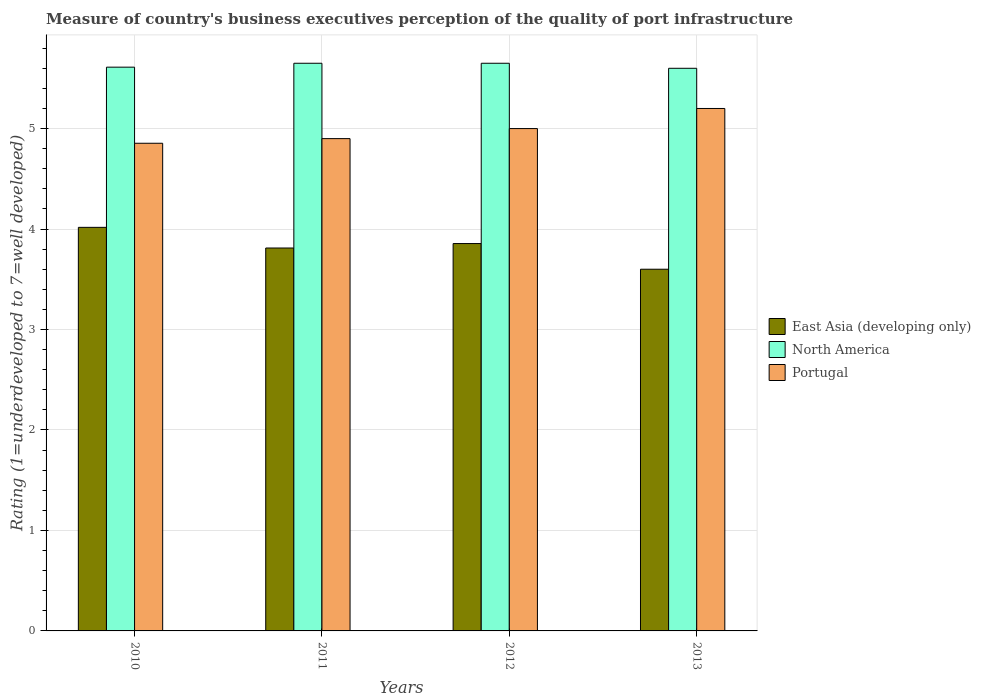How many different coloured bars are there?
Your response must be concise. 3. How many groups of bars are there?
Your answer should be compact. 4. Are the number of bars per tick equal to the number of legend labels?
Your answer should be very brief. Yes. How many bars are there on the 2nd tick from the right?
Make the answer very short. 3. What is the label of the 1st group of bars from the left?
Ensure brevity in your answer.  2010. What is the ratings of the quality of port infrastructure in North America in 2010?
Your answer should be very brief. 5.61. Across all years, what is the maximum ratings of the quality of port infrastructure in East Asia (developing only)?
Keep it short and to the point. 4.02. In which year was the ratings of the quality of port infrastructure in North America maximum?
Make the answer very short. 2011. In which year was the ratings of the quality of port infrastructure in Portugal minimum?
Your response must be concise. 2010. What is the total ratings of the quality of port infrastructure in Portugal in the graph?
Provide a short and direct response. 19.95. What is the difference between the ratings of the quality of port infrastructure in Portugal in 2010 and that in 2013?
Give a very brief answer. -0.35. What is the difference between the ratings of the quality of port infrastructure in Portugal in 2012 and the ratings of the quality of port infrastructure in North America in 2013?
Make the answer very short. -0.6. What is the average ratings of the quality of port infrastructure in North America per year?
Make the answer very short. 5.63. In the year 2010, what is the difference between the ratings of the quality of port infrastructure in East Asia (developing only) and ratings of the quality of port infrastructure in Portugal?
Your answer should be very brief. -0.84. What is the ratio of the ratings of the quality of port infrastructure in Portugal in 2010 to that in 2012?
Provide a short and direct response. 0.97. Is the ratings of the quality of port infrastructure in Portugal in 2010 less than that in 2013?
Provide a short and direct response. Yes. Is the difference between the ratings of the quality of port infrastructure in East Asia (developing only) in 2010 and 2012 greater than the difference between the ratings of the quality of port infrastructure in Portugal in 2010 and 2012?
Keep it short and to the point. Yes. What is the difference between the highest and the second highest ratings of the quality of port infrastructure in Portugal?
Your answer should be compact. 0.2. What is the difference between the highest and the lowest ratings of the quality of port infrastructure in East Asia (developing only)?
Make the answer very short. 0.42. In how many years, is the ratings of the quality of port infrastructure in East Asia (developing only) greater than the average ratings of the quality of port infrastructure in East Asia (developing only) taken over all years?
Provide a short and direct response. 2. Is the sum of the ratings of the quality of port infrastructure in North America in 2011 and 2013 greater than the maximum ratings of the quality of port infrastructure in Portugal across all years?
Your answer should be very brief. Yes. What does the 3rd bar from the left in 2010 represents?
Offer a terse response. Portugal. What does the 3rd bar from the right in 2013 represents?
Ensure brevity in your answer.  East Asia (developing only). Is it the case that in every year, the sum of the ratings of the quality of port infrastructure in Portugal and ratings of the quality of port infrastructure in East Asia (developing only) is greater than the ratings of the quality of port infrastructure in North America?
Your answer should be very brief. Yes. Are all the bars in the graph horizontal?
Your answer should be compact. No. Are the values on the major ticks of Y-axis written in scientific E-notation?
Provide a short and direct response. No. Does the graph contain any zero values?
Offer a very short reply. No. How many legend labels are there?
Provide a short and direct response. 3. How are the legend labels stacked?
Your answer should be very brief. Vertical. What is the title of the graph?
Give a very brief answer. Measure of country's business executives perception of the quality of port infrastructure. Does "Korea (Democratic)" appear as one of the legend labels in the graph?
Keep it short and to the point. No. What is the label or title of the Y-axis?
Offer a terse response. Rating (1=underdeveloped to 7=well developed). What is the Rating (1=underdeveloped to 7=well developed) of East Asia (developing only) in 2010?
Offer a very short reply. 4.02. What is the Rating (1=underdeveloped to 7=well developed) in North America in 2010?
Your answer should be very brief. 5.61. What is the Rating (1=underdeveloped to 7=well developed) in Portugal in 2010?
Your answer should be compact. 4.85. What is the Rating (1=underdeveloped to 7=well developed) in East Asia (developing only) in 2011?
Keep it short and to the point. 3.81. What is the Rating (1=underdeveloped to 7=well developed) in North America in 2011?
Offer a terse response. 5.65. What is the Rating (1=underdeveloped to 7=well developed) in Portugal in 2011?
Your answer should be compact. 4.9. What is the Rating (1=underdeveloped to 7=well developed) in East Asia (developing only) in 2012?
Keep it short and to the point. 3.86. What is the Rating (1=underdeveloped to 7=well developed) of North America in 2012?
Give a very brief answer. 5.65. Across all years, what is the maximum Rating (1=underdeveloped to 7=well developed) in East Asia (developing only)?
Give a very brief answer. 4.02. Across all years, what is the maximum Rating (1=underdeveloped to 7=well developed) of North America?
Offer a terse response. 5.65. Across all years, what is the minimum Rating (1=underdeveloped to 7=well developed) of East Asia (developing only)?
Your answer should be compact. 3.6. Across all years, what is the minimum Rating (1=underdeveloped to 7=well developed) of Portugal?
Keep it short and to the point. 4.85. What is the total Rating (1=underdeveloped to 7=well developed) in East Asia (developing only) in the graph?
Keep it short and to the point. 15.28. What is the total Rating (1=underdeveloped to 7=well developed) in North America in the graph?
Offer a terse response. 22.51. What is the total Rating (1=underdeveloped to 7=well developed) of Portugal in the graph?
Make the answer very short. 19.95. What is the difference between the Rating (1=underdeveloped to 7=well developed) of East Asia (developing only) in 2010 and that in 2011?
Your response must be concise. 0.21. What is the difference between the Rating (1=underdeveloped to 7=well developed) of North America in 2010 and that in 2011?
Keep it short and to the point. -0.04. What is the difference between the Rating (1=underdeveloped to 7=well developed) in Portugal in 2010 and that in 2011?
Your response must be concise. -0.05. What is the difference between the Rating (1=underdeveloped to 7=well developed) of East Asia (developing only) in 2010 and that in 2012?
Keep it short and to the point. 0.16. What is the difference between the Rating (1=underdeveloped to 7=well developed) in North America in 2010 and that in 2012?
Your answer should be compact. -0.04. What is the difference between the Rating (1=underdeveloped to 7=well developed) of Portugal in 2010 and that in 2012?
Your answer should be very brief. -0.15. What is the difference between the Rating (1=underdeveloped to 7=well developed) in East Asia (developing only) in 2010 and that in 2013?
Provide a short and direct response. 0.42. What is the difference between the Rating (1=underdeveloped to 7=well developed) of North America in 2010 and that in 2013?
Ensure brevity in your answer.  0.01. What is the difference between the Rating (1=underdeveloped to 7=well developed) of Portugal in 2010 and that in 2013?
Your answer should be compact. -0.35. What is the difference between the Rating (1=underdeveloped to 7=well developed) in East Asia (developing only) in 2011 and that in 2012?
Ensure brevity in your answer.  -0.04. What is the difference between the Rating (1=underdeveloped to 7=well developed) of North America in 2011 and that in 2012?
Your response must be concise. 0. What is the difference between the Rating (1=underdeveloped to 7=well developed) of East Asia (developing only) in 2011 and that in 2013?
Ensure brevity in your answer.  0.21. What is the difference between the Rating (1=underdeveloped to 7=well developed) of Portugal in 2011 and that in 2013?
Ensure brevity in your answer.  -0.3. What is the difference between the Rating (1=underdeveloped to 7=well developed) in East Asia (developing only) in 2012 and that in 2013?
Your answer should be compact. 0.26. What is the difference between the Rating (1=underdeveloped to 7=well developed) in North America in 2012 and that in 2013?
Ensure brevity in your answer.  0.05. What is the difference between the Rating (1=underdeveloped to 7=well developed) in East Asia (developing only) in 2010 and the Rating (1=underdeveloped to 7=well developed) in North America in 2011?
Keep it short and to the point. -1.63. What is the difference between the Rating (1=underdeveloped to 7=well developed) in East Asia (developing only) in 2010 and the Rating (1=underdeveloped to 7=well developed) in Portugal in 2011?
Make the answer very short. -0.88. What is the difference between the Rating (1=underdeveloped to 7=well developed) in North America in 2010 and the Rating (1=underdeveloped to 7=well developed) in Portugal in 2011?
Keep it short and to the point. 0.71. What is the difference between the Rating (1=underdeveloped to 7=well developed) in East Asia (developing only) in 2010 and the Rating (1=underdeveloped to 7=well developed) in North America in 2012?
Offer a very short reply. -1.63. What is the difference between the Rating (1=underdeveloped to 7=well developed) in East Asia (developing only) in 2010 and the Rating (1=underdeveloped to 7=well developed) in Portugal in 2012?
Ensure brevity in your answer.  -0.98. What is the difference between the Rating (1=underdeveloped to 7=well developed) in North America in 2010 and the Rating (1=underdeveloped to 7=well developed) in Portugal in 2012?
Your response must be concise. 0.61. What is the difference between the Rating (1=underdeveloped to 7=well developed) of East Asia (developing only) in 2010 and the Rating (1=underdeveloped to 7=well developed) of North America in 2013?
Keep it short and to the point. -1.58. What is the difference between the Rating (1=underdeveloped to 7=well developed) of East Asia (developing only) in 2010 and the Rating (1=underdeveloped to 7=well developed) of Portugal in 2013?
Provide a succinct answer. -1.18. What is the difference between the Rating (1=underdeveloped to 7=well developed) in North America in 2010 and the Rating (1=underdeveloped to 7=well developed) in Portugal in 2013?
Ensure brevity in your answer.  0.41. What is the difference between the Rating (1=underdeveloped to 7=well developed) in East Asia (developing only) in 2011 and the Rating (1=underdeveloped to 7=well developed) in North America in 2012?
Provide a succinct answer. -1.84. What is the difference between the Rating (1=underdeveloped to 7=well developed) of East Asia (developing only) in 2011 and the Rating (1=underdeveloped to 7=well developed) of Portugal in 2012?
Give a very brief answer. -1.19. What is the difference between the Rating (1=underdeveloped to 7=well developed) of North America in 2011 and the Rating (1=underdeveloped to 7=well developed) of Portugal in 2012?
Your response must be concise. 0.65. What is the difference between the Rating (1=underdeveloped to 7=well developed) in East Asia (developing only) in 2011 and the Rating (1=underdeveloped to 7=well developed) in North America in 2013?
Your response must be concise. -1.79. What is the difference between the Rating (1=underdeveloped to 7=well developed) in East Asia (developing only) in 2011 and the Rating (1=underdeveloped to 7=well developed) in Portugal in 2013?
Your answer should be compact. -1.39. What is the difference between the Rating (1=underdeveloped to 7=well developed) in North America in 2011 and the Rating (1=underdeveloped to 7=well developed) in Portugal in 2013?
Ensure brevity in your answer.  0.45. What is the difference between the Rating (1=underdeveloped to 7=well developed) in East Asia (developing only) in 2012 and the Rating (1=underdeveloped to 7=well developed) in North America in 2013?
Offer a very short reply. -1.74. What is the difference between the Rating (1=underdeveloped to 7=well developed) in East Asia (developing only) in 2012 and the Rating (1=underdeveloped to 7=well developed) in Portugal in 2013?
Ensure brevity in your answer.  -1.34. What is the difference between the Rating (1=underdeveloped to 7=well developed) of North America in 2012 and the Rating (1=underdeveloped to 7=well developed) of Portugal in 2013?
Your response must be concise. 0.45. What is the average Rating (1=underdeveloped to 7=well developed) of East Asia (developing only) per year?
Provide a succinct answer. 3.82. What is the average Rating (1=underdeveloped to 7=well developed) of North America per year?
Your response must be concise. 5.63. What is the average Rating (1=underdeveloped to 7=well developed) of Portugal per year?
Keep it short and to the point. 4.99. In the year 2010, what is the difference between the Rating (1=underdeveloped to 7=well developed) in East Asia (developing only) and Rating (1=underdeveloped to 7=well developed) in North America?
Ensure brevity in your answer.  -1.59. In the year 2010, what is the difference between the Rating (1=underdeveloped to 7=well developed) in East Asia (developing only) and Rating (1=underdeveloped to 7=well developed) in Portugal?
Your response must be concise. -0.84. In the year 2010, what is the difference between the Rating (1=underdeveloped to 7=well developed) in North America and Rating (1=underdeveloped to 7=well developed) in Portugal?
Give a very brief answer. 0.76. In the year 2011, what is the difference between the Rating (1=underdeveloped to 7=well developed) of East Asia (developing only) and Rating (1=underdeveloped to 7=well developed) of North America?
Make the answer very short. -1.84. In the year 2011, what is the difference between the Rating (1=underdeveloped to 7=well developed) in East Asia (developing only) and Rating (1=underdeveloped to 7=well developed) in Portugal?
Make the answer very short. -1.09. In the year 2012, what is the difference between the Rating (1=underdeveloped to 7=well developed) in East Asia (developing only) and Rating (1=underdeveloped to 7=well developed) in North America?
Your answer should be very brief. -1.79. In the year 2012, what is the difference between the Rating (1=underdeveloped to 7=well developed) in East Asia (developing only) and Rating (1=underdeveloped to 7=well developed) in Portugal?
Provide a succinct answer. -1.14. In the year 2012, what is the difference between the Rating (1=underdeveloped to 7=well developed) in North America and Rating (1=underdeveloped to 7=well developed) in Portugal?
Ensure brevity in your answer.  0.65. In the year 2013, what is the difference between the Rating (1=underdeveloped to 7=well developed) in East Asia (developing only) and Rating (1=underdeveloped to 7=well developed) in North America?
Give a very brief answer. -2. What is the ratio of the Rating (1=underdeveloped to 7=well developed) of East Asia (developing only) in 2010 to that in 2011?
Keep it short and to the point. 1.05. What is the ratio of the Rating (1=underdeveloped to 7=well developed) of East Asia (developing only) in 2010 to that in 2012?
Offer a very short reply. 1.04. What is the ratio of the Rating (1=underdeveloped to 7=well developed) of Portugal in 2010 to that in 2012?
Offer a very short reply. 0.97. What is the ratio of the Rating (1=underdeveloped to 7=well developed) in East Asia (developing only) in 2010 to that in 2013?
Keep it short and to the point. 1.12. What is the ratio of the Rating (1=underdeveloped to 7=well developed) of Portugal in 2010 to that in 2013?
Ensure brevity in your answer.  0.93. What is the ratio of the Rating (1=underdeveloped to 7=well developed) of East Asia (developing only) in 2011 to that in 2012?
Keep it short and to the point. 0.99. What is the ratio of the Rating (1=underdeveloped to 7=well developed) in North America in 2011 to that in 2012?
Give a very brief answer. 1. What is the ratio of the Rating (1=underdeveloped to 7=well developed) in East Asia (developing only) in 2011 to that in 2013?
Make the answer very short. 1.06. What is the ratio of the Rating (1=underdeveloped to 7=well developed) of North America in 2011 to that in 2013?
Provide a short and direct response. 1.01. What is the ratio of the Rating (1=underdeveloped to 7=well developed) of Portugal in 2011 to that in 2013?
Offer a very short reply. 0.94. What is the ratio of the Rating (1=underdeveloped to 7=well developed) in East Asia (developing only) in 2012 to that in 2013?
Your response must be concise. 1.07. What is the ratio of the Rating (1=underdeveloped to 7=well developed) of North America in 2012 to that in 2013?
Your response must be concise. 1.01. What is the ratio of the Rating (1=underdeveloped to 7=well developed) of Portugal in 2012 to that in 2013?
Your response must be concise. 0.96. What is the difference between the highest and the second highest Rating (1=underdeveloped to 7=well developed) of East Asia (developing only)?
Give a very brief answer. 0.16. What is the difference between the highest and the second highest Rating (1=underdeveloped to 7=well developed) in Portugal?
Provide a short and direct response. 0.2. What is the difference between the highest and the lowest Rating (1=underdeveloped to 7=well developed) in East Asia (developing only)?
Offer a terse response. 0.42. What is the difference between the highest and the lowest Rating (1=underdeveloped to 7=well developed) of North America?
Your response must be concise. 0.05. What is the difference between the highest and the lowest Rating (1=underdeveloped to 7=well developed) of Portugal?
Make the answer very short. 0.35. 